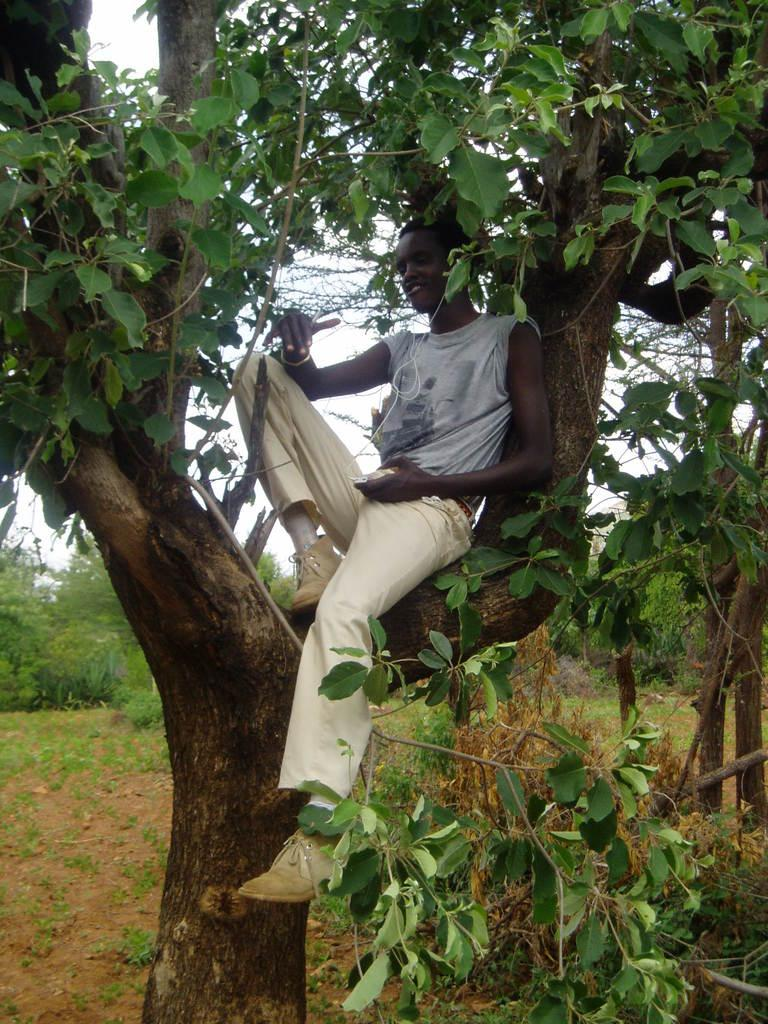Who is the main subject in the image? There is a boy in the image. What is the boy doing in the image? The boy is sitting on a tree. What is the boy wearing in the image? The boy is wearing a grey t-shirt and cream trousers. What can be seen in the background of the image? There are trees, plants, and the sky visible in the background of the image. What is the price of the cart in the image? There is no cart present in the image, so it is not possible to determine its price. 